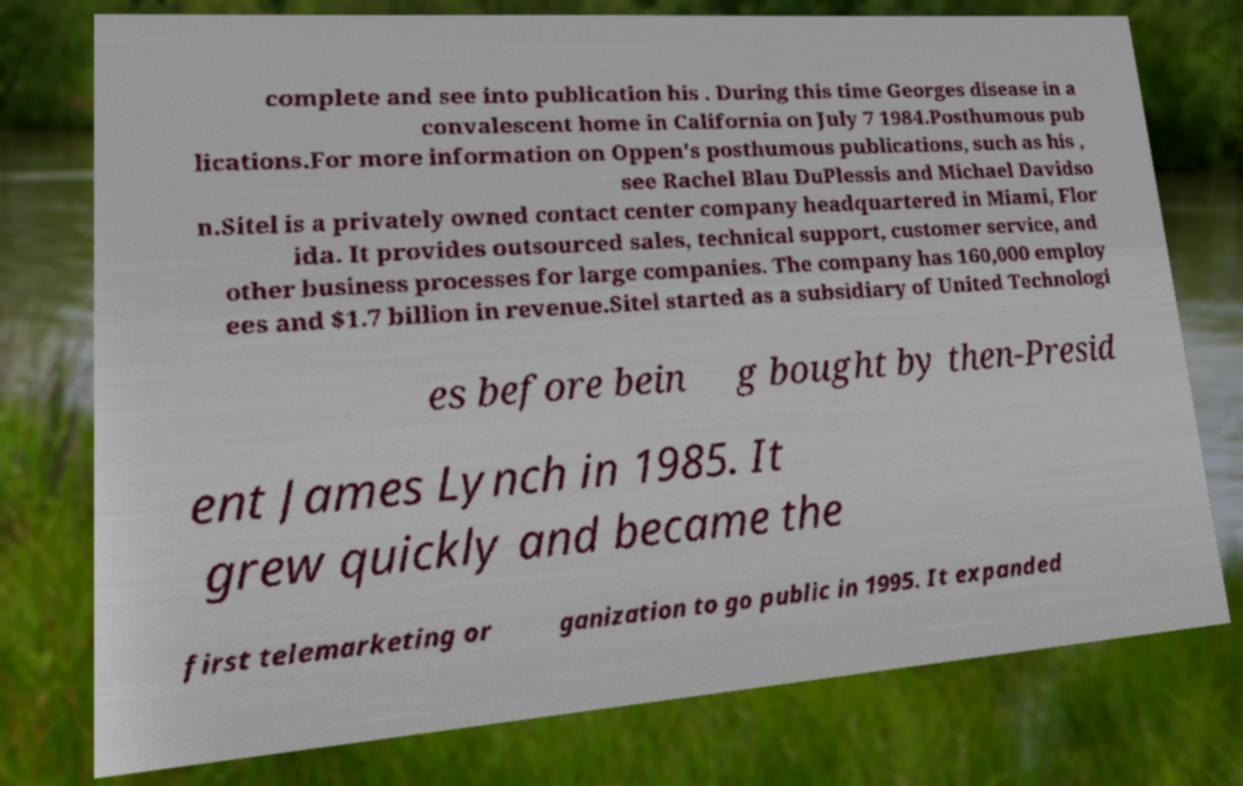Can you read and provide the text displayed in the image?This photo seems to have some interesting text. Can you extract and type it out for me? complete and see into publication his . During this time Georges disease in a convalescent home in California on July 7 1984.Posthumous pub lications.For more information on Oppen's posthumous publications, such as his , see Rachel Blau DuPlessis and Michael Davidso n.Sitel is a privately owned contact center company headquartered in Miami, Flor ida. It provides outsourced sales, technical support, customer service, and other business processes for large companies. The company has 160,000 employ ees and $1.7 billion in revenue.Sitel started as a subsidiary of United Technologi es before bein g bought by then-Presid ent James Lynch in 1985. It grew quickly and became the first telemarketing or ganization to go public in 1995. It expanded 